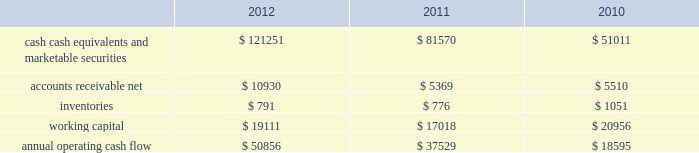35% ( 35 % ) due primarily to certain undistributed foreign earnings for which no u.s .
Taxes are provided because such earnings are intended to be indefinitely reinvested outside the u.s .
As of september 29 , 2012 , the company had deferred tax assets arising from deductible temporary differences , tax losses , and tax credits of $ 4.0 billion , and deferred tax liabilities of $ 14.9 billion .
Management believes it is more likely than not that forecasted income , including income that may be generated as a result of certain tax planning strategies , together with future reversals of existing taxable temporary differences , will be sufficient to fully recover the deferred tax assets .
The company will continue to evaluate the realizability of deferred tax assets quarterly by assessing the need for and amount of a valuation allowance .
The internal revenue service ( the 201cirs 201d ) has completed its field audit of the company 2019s federal income tax returns for the years 2004 through 2006 and proposed certain adjustments .
The company has contested certain of these adjustments through the irs appeals office .
The irs is currently examining the years 2007 through 2009 .
All irs audit issues for years prior to 2004 have been resolved .
In addition , the company is subject to audits by state , local , and foreign tax authorities .
Management believes that adequate provisions have been made for any adjustments that may result from tax examinations .
However , the outcome of tax audits cannot be predicted with certainty .
If any issues addressed in the company 2019s tax audits are resolved in a manner not consistent with management 2019s expectations , the company could be required to adjust its provision for income taxes in the period such resolution occurs .
Liquidity and capital resources the table presents selected financial information and statistics as of and for the years ended september 29 , 2012 , september 24 , 2011 , and september 25 , 2010 ( in millions ) : .
As of september 29 , 2012 , the company had $ 121.3 billion in cash , cash equivalents and marketable securities , an increase of $ 39.7 billion or 49% ( 49 % ) from september 24 , 2011 .
The principal components of this net increase was the cash generated by operating activities of $ 50.9 billion , which was partially offset by payments for acquisition of property , plant and equipment of $ 8.3 billion , payments for acquisition of intangible assets of $ 1.1 billion and payments of dividends and dividend equivalent rights of $ 2.5 billion .
The company 2019s marketable securities investment portfolio is invested primarily in highly-rated securities and its investment policy generally limits the amount of credit exposure to any one issuer .
The policy requires investments generally to be investment grade with the objective of minimizing the potential risk of principal loss .
As of september 29 , 2012 and september 24 , 2011 , $ 82.6 billion and $ 54.3 billion , respectively , of the company 2019s cash , cash equivalents and marketable securities were held by foreign subsidiaries and are generally based in u.s .
Dollar-denominated holdings .
Amounts held by foreign subsidiaries are generally subject to u.s .
Income taxation on repatriation to the u.s .
The company believes its existing balances of cash , cash equivalents and marketable securities will be sufficient to satisfy its working capital needs , capital asset purchases , outstanding commitments , common stock repurchases , dividends on its common stock , and other liquidity requirements associated with its existing operations over the next 12 months .
Capital assets the company 2019s capital expenditures were $ 10.3 billion during 2012 , consisting of $ 865 million for retail store facilities and $ 9.5 billion for other capital expenditures , including product tooling and manufacturing process .
What was the increase between september 29 , 2012 and september 24 , 2011 of the company 2019s cash , cash equivalents and marketable securities held by foreign subsidiaries? 
Computations: (82.6 - 54.3)
Answer: 28.3. 